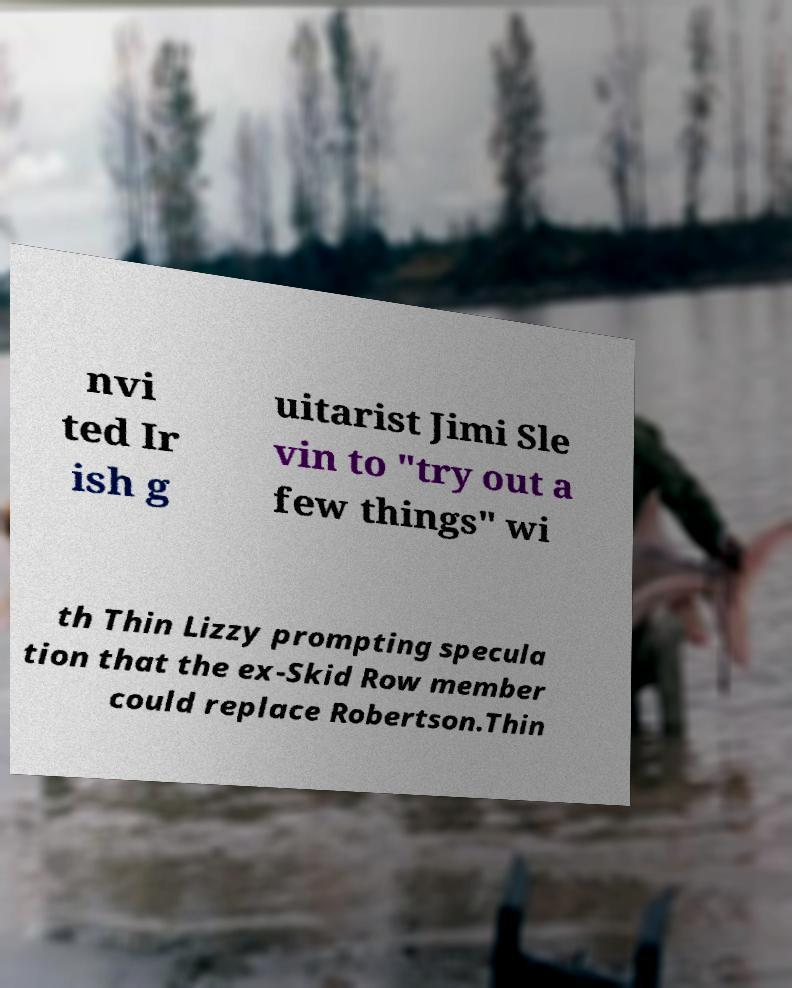Can you accurately transcribe the text from the provided image for me? nvi ted Ir ish g uitarist Jimi Sle vin to "try out a few things" wi th Thin Lizzy prompting specula tion that the ex-Skid Row member could replace Robertson.Thin 